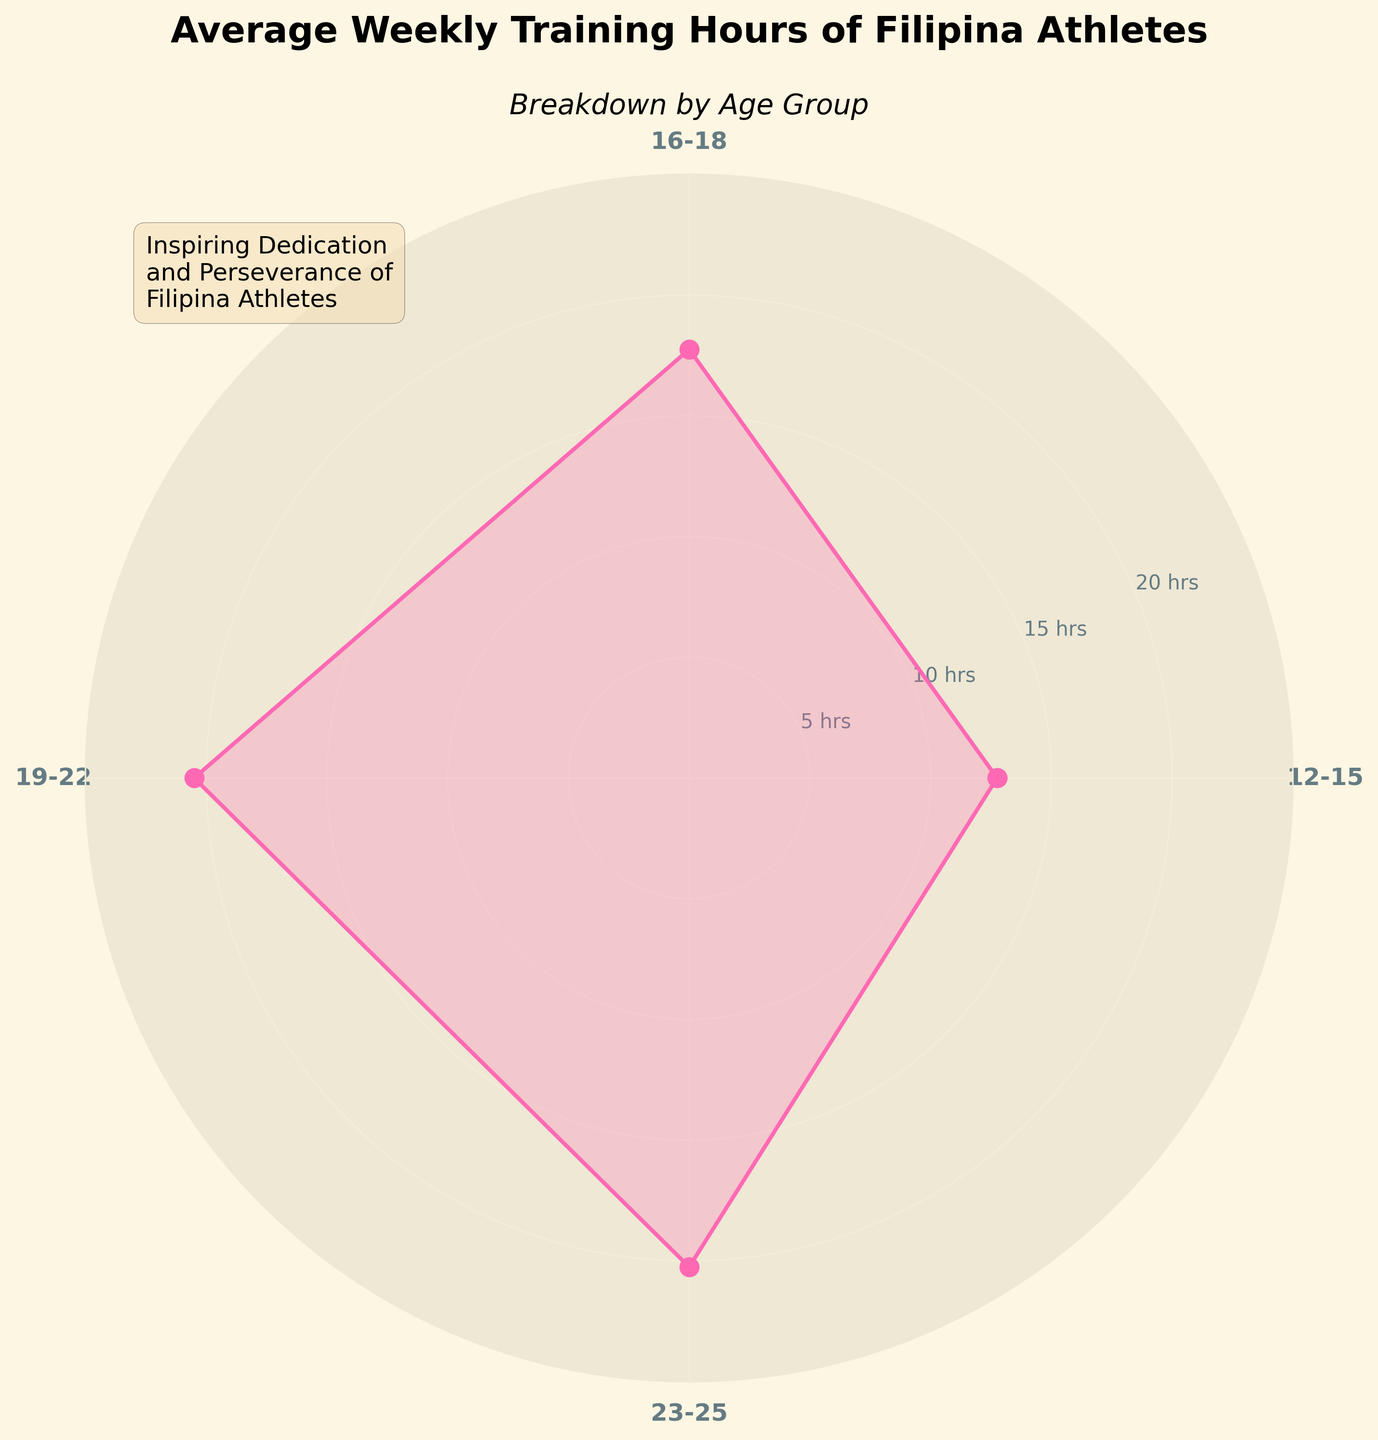What is the title of the figure? The title is usually found at the top of the figure and provides a summary of what the figure represents. In this case, it should indicate the main subject of the chart.
Answer: Average Weekly Training Hours of Filipina Athletes Which age group has the highest average weekly training hours? By looking at the chart, we need to identify the sector (angle) with the longest projection from the center to find the age group with the highest average training hours.
Answer: 19-22 What is the average weekly training hours for the age group 16-18? Locate the segment representing the 16-18 age group and read the corresponding value on the radial axis to get the average training hours.
Answer: 17.75 How many age groups are represented in the rose chart? Count the unique sectors in the rose chart, each representing a different age group.
Answer: 4 What is the average weekly training hours for the youngest age group (12-15)? Find the sector labeled 12-15 and check the value corresponding to this sector on the radial axis.
Answer: 12.75 Compare the average training hours of the age groups 16-18 and 19-22. Which one is higher and by how much? Identify the values for both age groups and then subtract the average hours of 16-18 from that of 19-22 to find the difference.
Answer: 19-22 is higher by 3.25 hours Which age group has the lowest average weekly training hours? Look for the sector with the shortest projection from the center to find the age group with the lowest average training hours.
Answer: 12-15 What are the y-axis labels increments on the rose chart? Examine the radial axis and note the intervals between the marked values.
Answer: 5 hrs By how much do the average weekly training hours increase from the youngest age group to the oldest age group? Subtract the average training hours of the 12-15 age group from the average training hours of the 23-25 age group.
Answer: 7.5 What’s the average weekly training hours for the age group 23-25? Look at the segment labeled 23-25 and read the corresponding value on the radial axis.
Answer: 20.25 